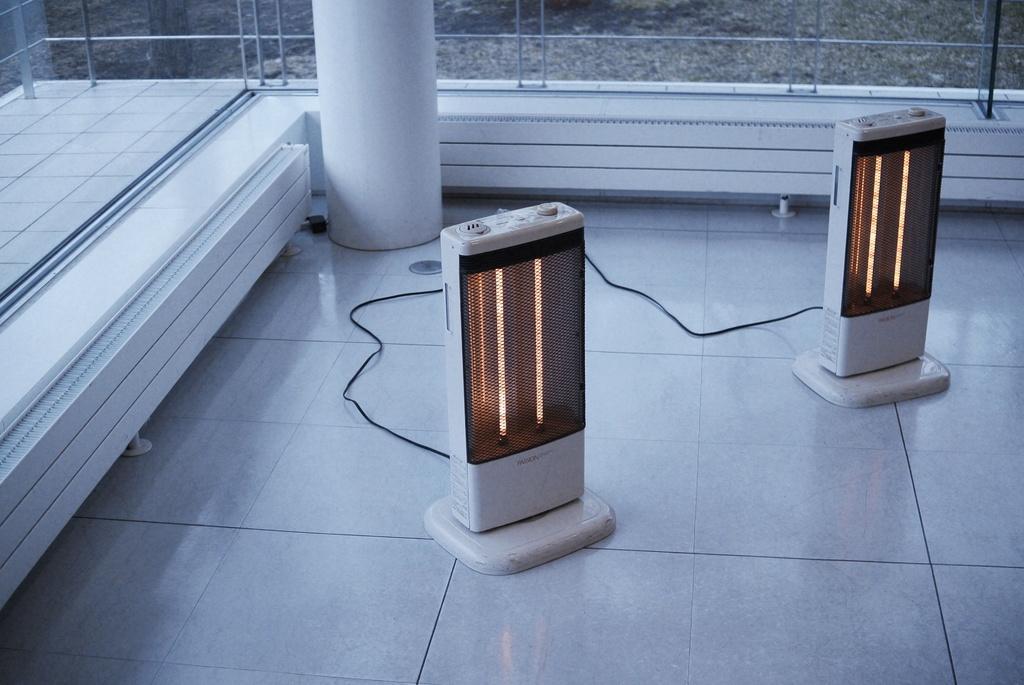Could you give a brief overview of what you see in this image? This image is taken indoors. At the bottom of the image there is a floor. In the background there is a glass wall and a pillar. In the middle of the image there are two lights on the floor. 